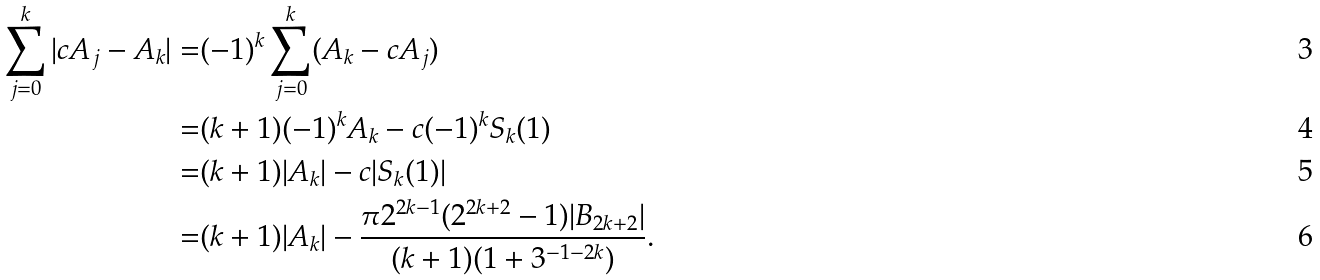Convert formula to latex. <formula><loc_0><loc_0><loc_500><loc_500>\sum _ { j = 0 } ^ { k } | c A _ { j } - A _ { k } | = & ( - 1 ) ^ { k } \sum _ { j = 0 } ^ { k } ( A _ { k } - c A _ { j } ) \\ = & ( k + 1 ) ( - 1 ) ^ { k } A _ { k } - c ( - 1 ) ^ { k } S _ { k } ( 1 ) \\ = & ( k + 1 ) | A _ { k } | - c | S _ { k } ( 1 ) | \\ = & ( k + 1 ) | A _ { k } | - \frac { \pi 2 ^ { 2 k - 1 } ( 2 ^ { 2 k + 2 } - 1 ) | B _ { 2 k + 2 } | } { ( k + 1 ) ( 1 + 3 ^ { - 1 - 2 k } ) } .</formula> 